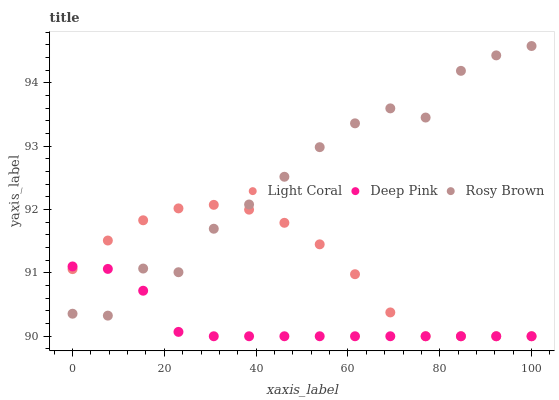Does Deep Pink have the minimum area under the curve?
Answer yes or no. Yes. Does Rosy Brown have the maximum area under the curve?
Answer yes or no. Yes. Does Rosy Brown have the minimum area under the curve?
Answer yes or no. No. Does Deep Pink have the maximum area under the curve?
Answer yes or no. No. Is Deep Pink the smoothest?
Answer yes or no. Yes. Is Rosy Brown the roughest?
Answer yes or no. Yes. Is Rosy Brown the smoothest?
Answer yes or no. No. Is Deep Pink the roughest?
Answer yes or no. No. Does Light Coral have the lowest value?
Answer yes or no. Yes. Does Rosy Brown have the lowest value?
Answer yes or no. No. Does Rosy Brown have the highest value?
Answer yes or no. Yes. Does Deep Pink have the highest value?
Answer yes or no. No. Does Rosy Brown intersect Deep Pink?
Answer yes or no. Yes. Is Rosy Brown less than Deep Pink?
Answer yes or no. No. Is Rosy Brown greater than Deep Pink?
Answer yes or no. No. 